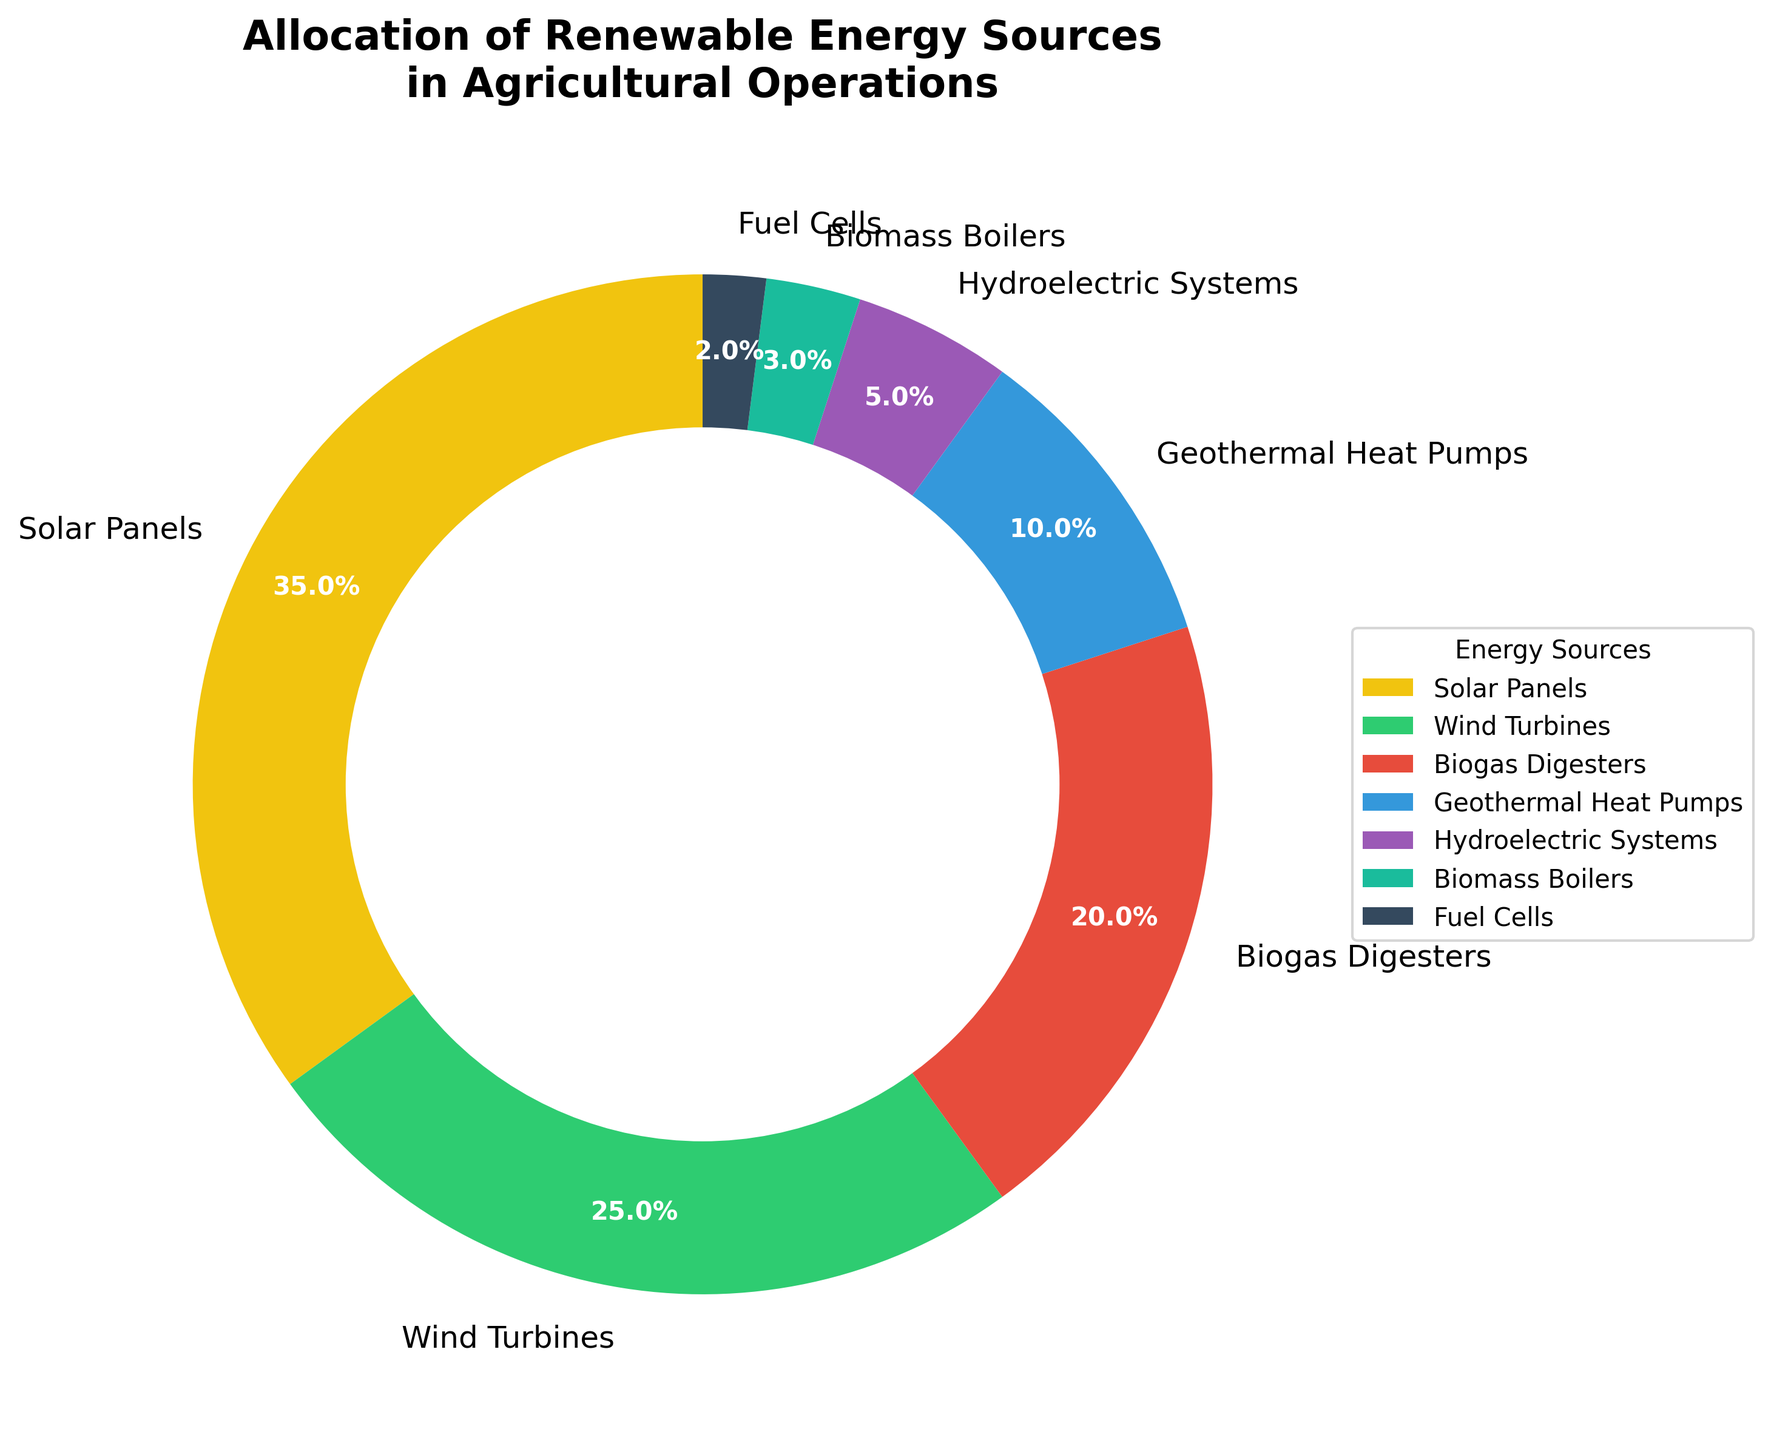What is the most utilized renewable energy source in agricultural operations according to the pie chart? The largest segment in the pie chart represents Solar Panels, taking up 35% of the total allocation, which indicates that Solar Panels are the most utilized renewable energy source in agricultural operations.
Answer: Solar Panels Which energy source is allocated 25% of the total in agricultural operations? By looking at the segments labeled around the pie chart, we see that Wind Turbines are allocated 25%.
Answer: Wind Turbines What is the difference in percentage between the usage of Solar Panels and Wind Turbines? Solar Panels have a percentage of 35%, while Wind Turbines are at 25%. The difference is calculated as 35% - 25% = 10%.
Answer: 10% Add the percentages of Biogas Digesters and Geothermal Heat Pumps and provide the total percentage they represent together. The chart shows that Biogas Digesters account for 20% and Geothermal Heat Pumps for 10%. Adding these together: 20% + 10% = 30%.
Answer: 30% Which two energy sources combined make up exactly one-quarter of the total allocation in agricultural operations? Searching for segments that add up to 25%, we see Geothermal Heat Pumps (10%) and Hydroelectric Systems (5%) combined with Fuel Cells (2%) and Biomass Boilers (3%). Neither Biogas Digesters (20%) nor any other sources fit the criteria alone or in combination, therefore, the correct combination does not exist in the given total allocation.
Answer: None Rank the energy sources from most to least utilized according to the pie chart. Referring to the chart, the percentages are: Solar Panels (35%), Wind Turbines (25%), Biogas Digesters (20%), Geothermal Heat Pumps (10%), Hydroelectric Systems (5%), Biomass Boilers (3%), Fuel Cells (2%). The order from most to least utilized is Solar Panels, Wind Turbines, Biogas Digesters, Geothermal Heat Pumps, Hydroelectric Systems, Biomass Boilers, and Fuel Cells.
Answer: Solar Panels, Wind Turbines, Biogas Digesters, Geothermal Heat Pumps, Hydroelectric Systems, Biomass Boilers, Fuel Cells What is the combined percentage of the three least utilized energy sources in the pie chart? The three least utilized energy sources are Hydroelectric Systems (5%), Biomass Boilers (3%), and Fuel Cells (2%). Adding these together: 5% + 3% + 2% = 10%.
Answer: 10% What percentage is represented by renewable energy sources other than Solar Panels and Wind Turbines? Solar Panels account for 35% and Wind Turbines for 25%. Together, they account for 60%. The remaining percentage is 100% - 60% = 40%, shared by other sources.
Answer: 40% Which energy source is depicted with the least allocation and what is its percentage? The smallest segment in the pie chart represents Fuel Cells, which is allocated 2%.
Answer: Fuel Cells, 2% Which energy sources are represented using green and blue colors respectively in the pie chart? Referring to the colors in the legend, the green segment corresponds to Wind Turbines, and the blue segment corresponds to Geothermal Heat Pumps.
Answer: Green: Wind Turbines, Blue: Geothermal Heat Pumps 